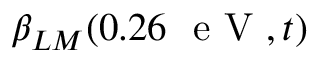<formula> <loc_0><loc_0><loc_500><loc_500>\beta _ { L M } ( 0 . 2 6 \ e V , t )</formula> 